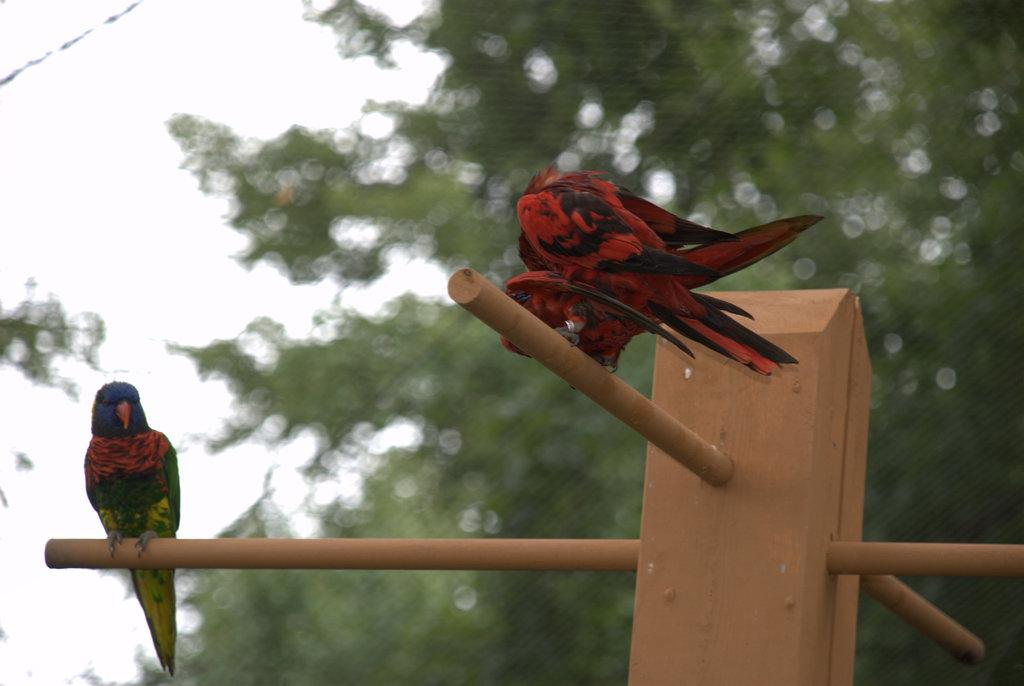How many parrots are in the image? There are two parrots in the image. What are the parrots sitting on? The parrots are sitting on a rod. What can be seen in the background of the image? There are trees and the sky visible in the background of the image. When was the image taken? The image was taken during the day. What type of throat medicine is the parrot holding in the image? There is no throat medicine present in the image; the parrots are simply sitting on a rod. 